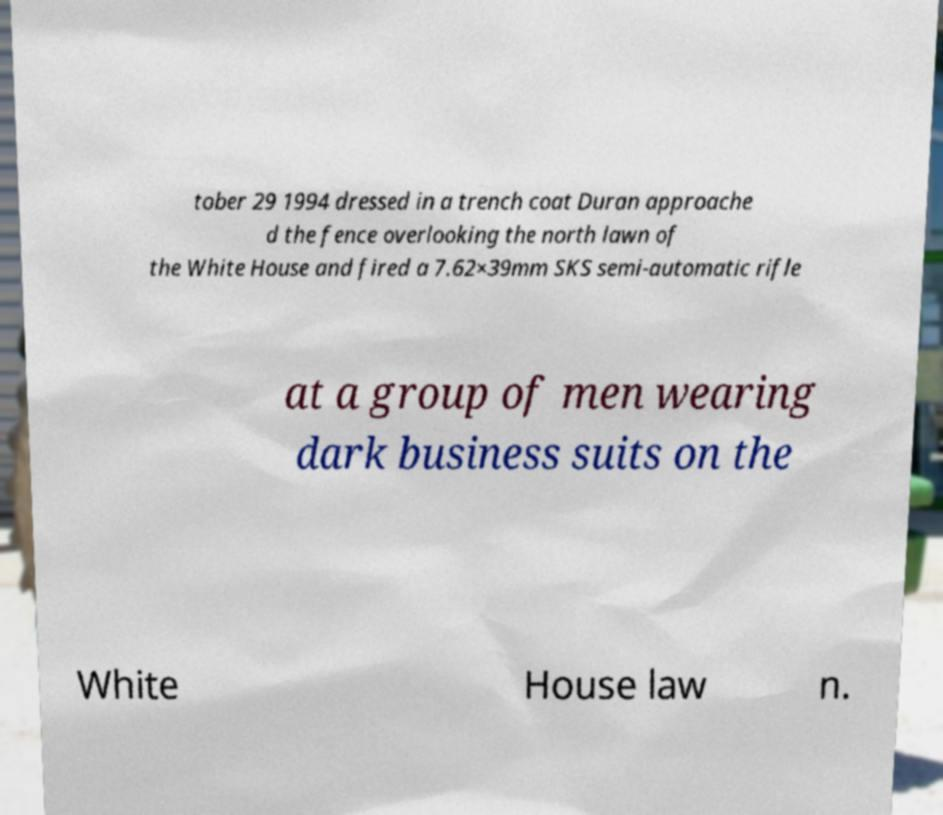There's text embedded in this image that I need extracted. Can you transcribe it verbatim? tober 29 1994 dressed in a trench coat Duran approache d the fence overlooking the north lawn of the White House and fired a 7.62×39mm SKS semi-automatic rifle at a group of men wearing dark business suits on the White House law n. 